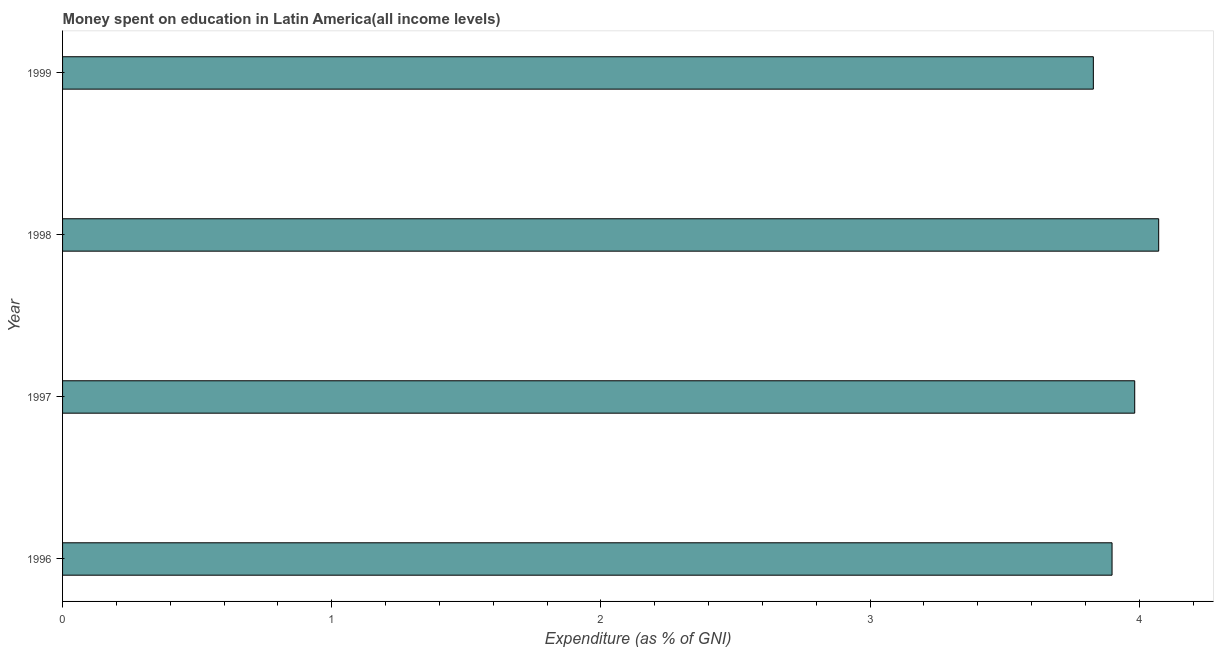Does the graph contain any zero values?
Ensure brevity in your answer.  No. Does the graph contain grids?
Give a very brief answer. No. What is the title of the graph?
Keep it short and to the point. Money spent on education in Latin America(all income levels). What is the label or title of the X-axis?
Keep it short and to the point. Expenditure (as % of GNI). What is the expenditure on education in 1999?
Provide a succinct answer. 3.83. Across all years, what is the maximum expenditure on education?
Give a very brief answer. 4.07. Across all years, what is the minimum expenditure on education?
Your response must be concise. 3.83. What is the sum of the expenditure on education?
Ensure brevity in your answer.  15.78. What is the difference between the expenditure on education in 1998 and 1999?
Your answer should be compact. 0.24. What is the average expenditure on education per year?
Keep it short and to the point. 3.95. What is the median expenditure on education?
Provide a succinct answer. 3.94. Do a majority of the years between 1999 and 1996 (inclusive) have expenditure on education greater than 0.6 %?
Your answer should be very brief. Yes. Is the difference between the expenditure on education in 1996 and 1998 greater than the difference between any two years?
Offer a terse response. No. What is the difference between the highest and the second highest expenditure on education?
Offer a terse response. 0.09. What is the difference between the highest and the lowest expenditure on education?
Provide a short and direct response. 0.24. How many bars are there?
Keep it short and to the point. 4. What is the Expenditure (as % of GNI) in 1996?
Your answer should be compact. 3.9. What is the Expenditure (as % of GNI) in 1997?
Offer a very short reply. 3.98. What is the Expenditure (as % of GNI) of 1998?
Give a very brief answer. 4.07. What is the Expenditure (as % of GNI) of 1999?
Keep it short and to the point. 3.83. What is the difference between the Expenditure (as % of GNI) in 1996 and 1997?
Your answer should be very brief. -0.08. What is the difference between the Expenditure (as % of GNI) in 1996 and 1998?
Provide a short and direct response. -0.17. What is the difference between the Expenditure (as % of GNI) in 1996 and 1999?
Keep it short and to the point. 0.07. What is the difference between the Expenditure (as % of GNI) in 1997 and 1998?
Your answer should be compact. -0.09. What is the difference between the Expenditure (as % of GNI) in 1997 and 1999?
Provide a short and direct response. 0.15. What is the difference between the Expenditure (as % of GNI) in 1998 and 1999?
Make the answer very short. 0.24. What is the ratio of the Expenditure (as % of GNI) in 1996 to that in 1997?
Your response must be concise. 0.98. What is the ratio of the Expenditure (as % of GNI) in 1996 to that in 1998?
Provide a short and direct response. 0.96. What is the ratio of the Expenditure (as % of GNI) in 1997 to that in 1998?
Give a very brief answer. 0.98. What is the ratio of the Expenditure (as % of GNI) in 1997 to that in 1999?
Offer a very short reply. 1.04. What is the ratio of the Expenditure (as % of GNI) in 1998 to that in 1999?
Keep it short and to the point. 1.06. 